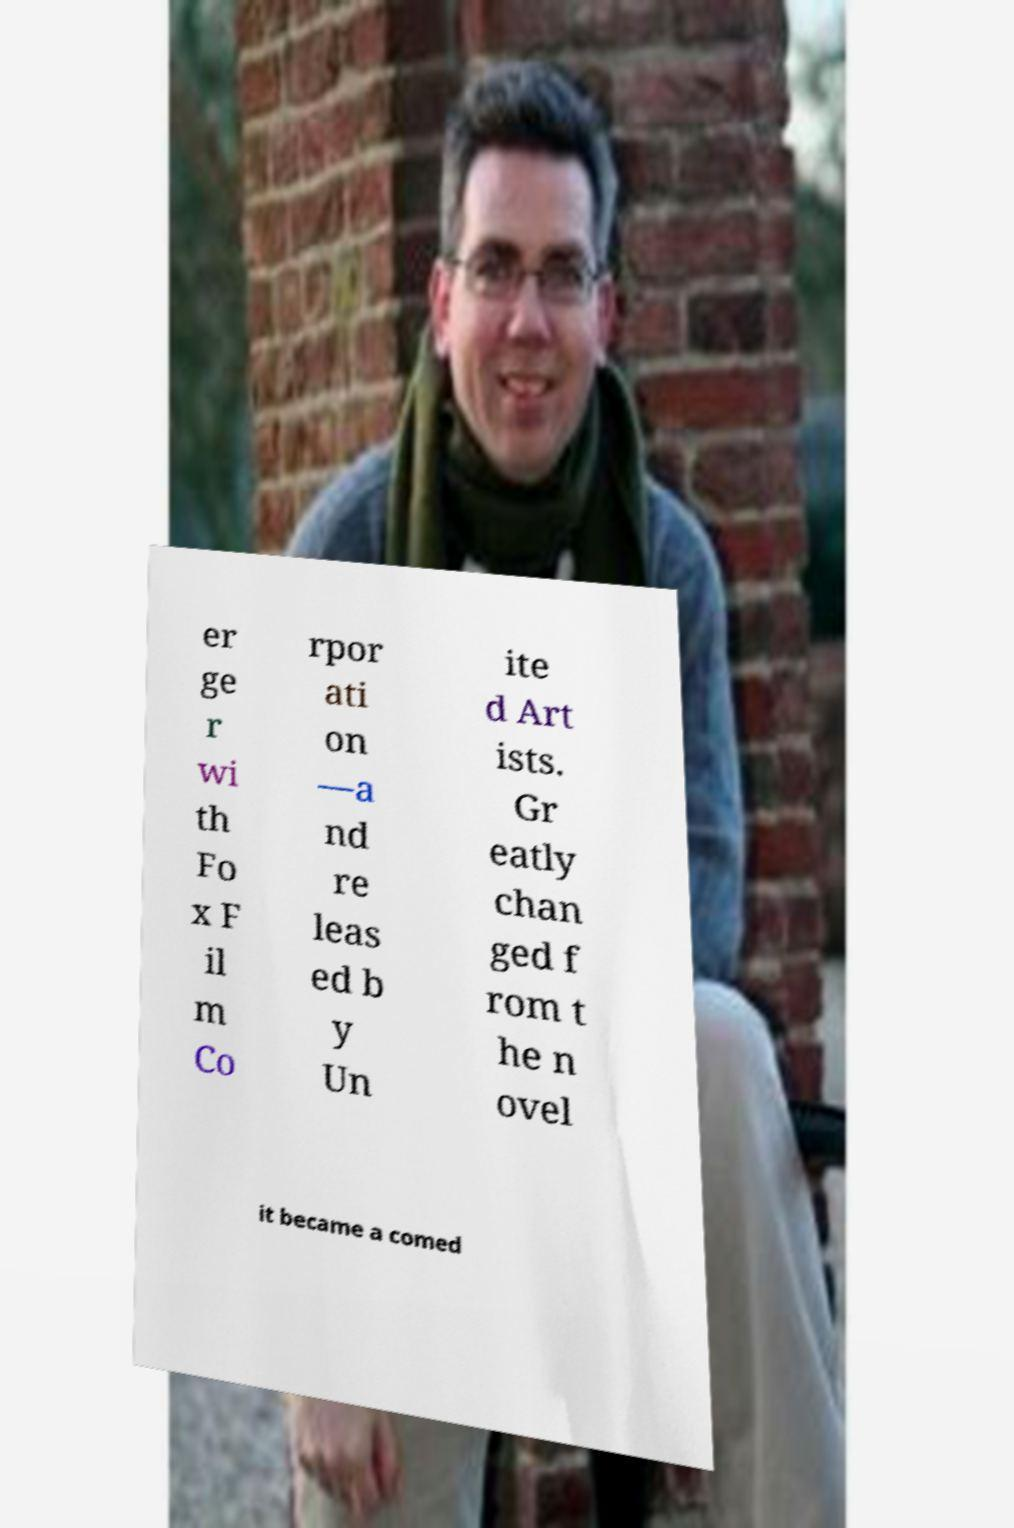Please read and relay the text visible in this image. What does it say? er ge r wi th Fo x F il m Co rpor ati on —a nd re leas ed b y Un ite d Art ists. Gr eatly chan ged f rom t he n ovel it became a comed 